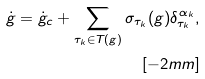Convert formula to latex. <formula><loc_0><loc_0><loc_500><loc_500>\dot { g } = \dot { g } _ { c } + \sum _ { \tau _ { k } \in T ( g ) } \sigma _ { \tau _ { k } } ( g ) \delta _ { \tau _ { k } } ^ { \alpha _ { k } } , \\ [ - 2 m m ]</formula> 